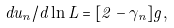Convert formula to latex. <formula><loc_0><loc_0><loc_500><loc_500>d u _ { n } / d \ln L = [ 2 - \gamma _ { n } ] g ,</formula> 